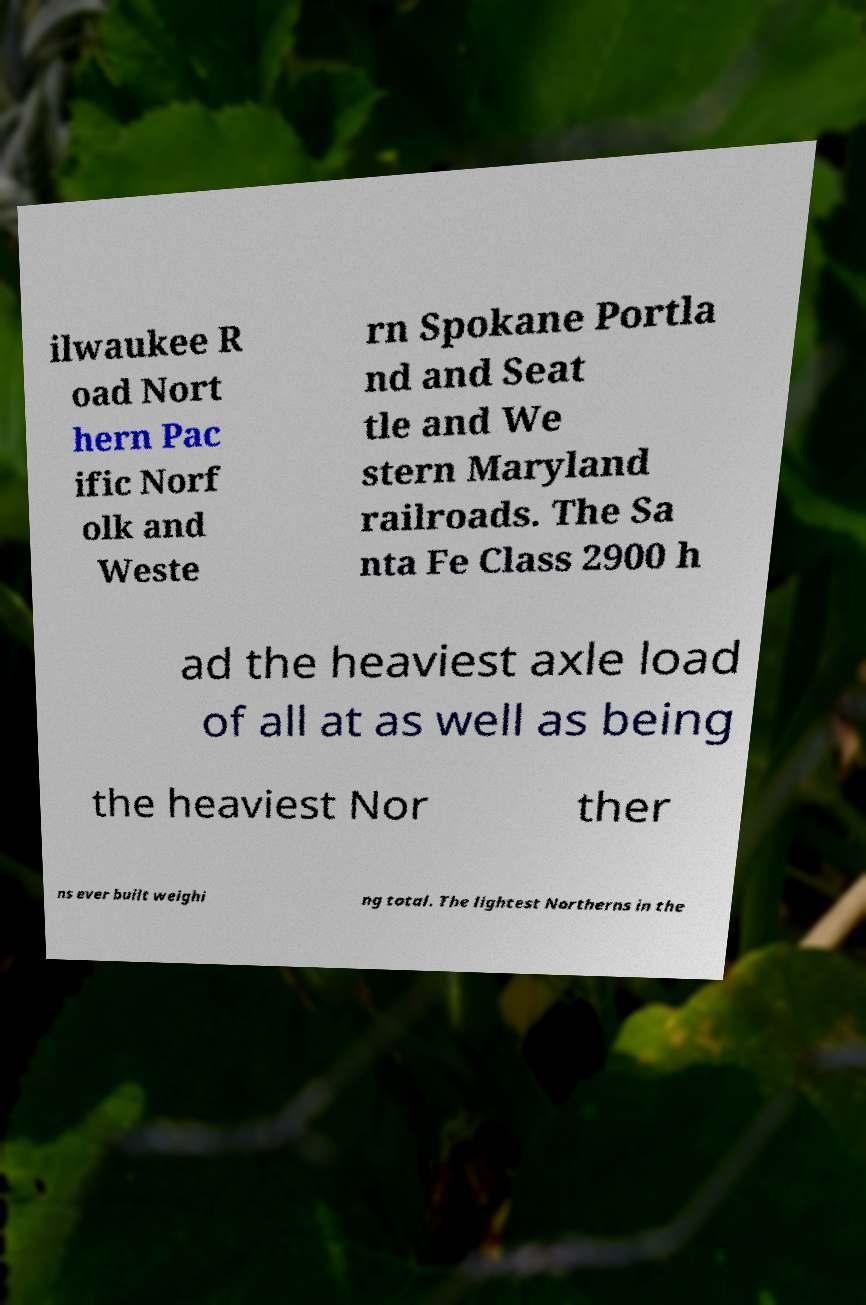Could you extract and type out the text from this image? ilwaukee R oad Nort hern Pac ific Norf olk and Weste rn Spokane Portla nd and Seat tle and We stern Maryland railroads. The Sa nta Fe Class 2900 h ad the heaviest axle load of all at as well as being the heaviest Nor ther ns ever built weighi ng total. The lightest Northerns in the 